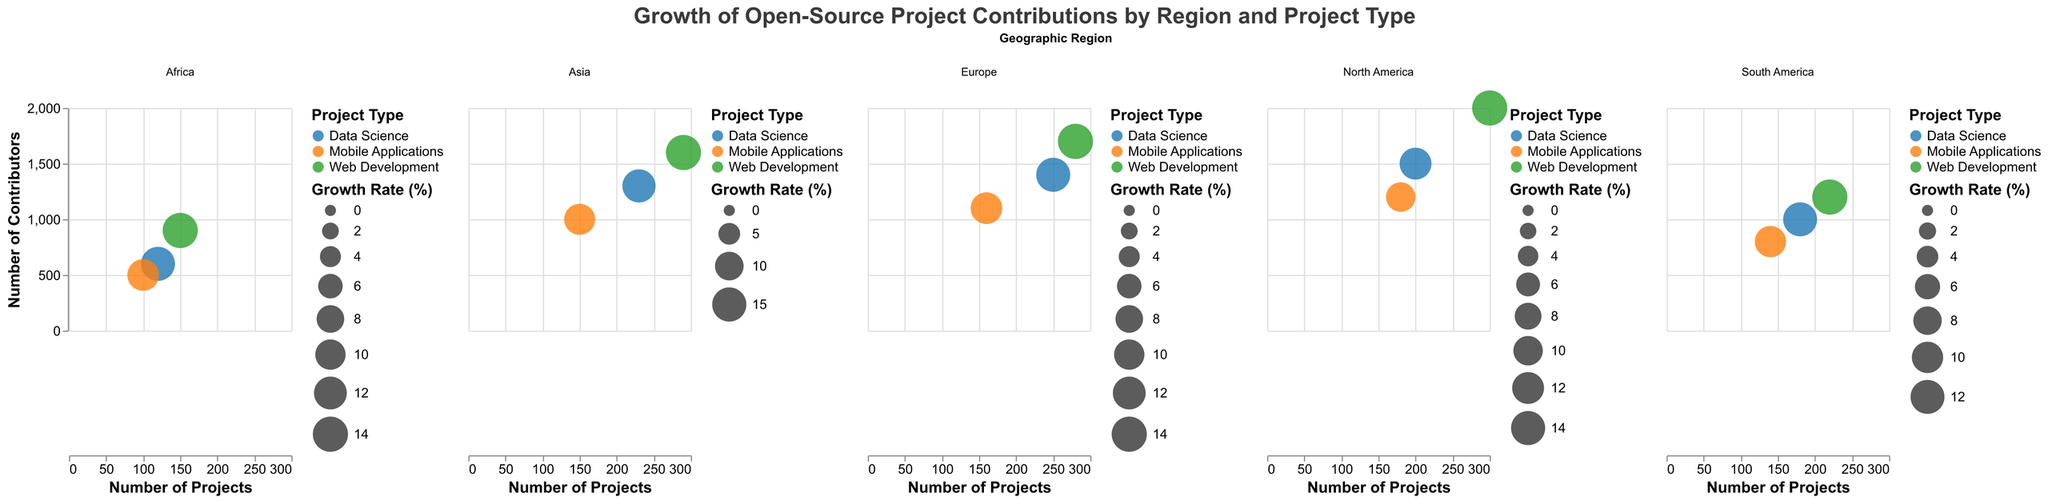Which geographic region has the highest number of contributors for web development? To determine the region with the highest number of contributors for web development, look at the subplot for each region and compare the "Number of Contributors" for the "Web Development" category. The North America subplot shows 2000 contributors, which is higher than other regions.
Answer: North America What is the growth rate for mobile applications in Asia? To find the growth rate for mobile applications in Asia, look at the Asia region in the subplot and identify the growth rate value associated with "Mobile Applications" bubble. The figure shows a growth rate of 12%.
Answer: 12% Which region has the lowest number of projects in data science? To determine the region with the lowest number of projects in data science, examine the number of projects for the "Data Science" category across all regions. Africa has 120 projects, which is the lowest number.
Answer: Africa Compare the growth rates for web development projects between North America and South America. Which one is higher? To compare growth rates, look at the "Web Development" bubbles in the North America and South America subplots. North America has a growth rate of 15%, while South America has a growth rate of 13%. Therefore, North America's growth rate is higher.
Answer: North America What is the total number of contributors for mobile applications in North America and Europe combined? To find the total number of contributors for mobile applications in North America and Europe, add the contributors in these regions: 1200 (North America) + 1100 (Europe). This results in a total of 2300 contributors.
Answer: 2300 Which project type in Europe has the highest growth rate, and what is the value? Look at the subplot for Europe and compare the growth rates for different project types. Web Development has a growth rate of 14%, Data Science has 13%, and Mobile Applications has 11%. The highest growth rate is for Web Development at 14%.
Answer: Web Development, 14% How does the number of projects in data science in Asia compare to the number of projects in mobile applications in North America? To compare, look at the "Projects" value for data science in Asia, which is 230, and for mobile applications in North America, which is 180. Asia's data science projects exceed North America's mobile application projects by 50.
Answer: Data science in Asia has 50 more projects What is the average growth rate for all project types in Africa? To find the average growth rate for all project types in Africa, sum the growth rates and divide by the number of project types: (14 + 13 + 11) / 3. This results in an average growth rate of 12.67%.
Answer: 12.67% Which regions have a higher number of contributors for data science than for mobile applications? Compare the number of contributors for data science and mobile applications in each region. In North America (1500 > 1200), Europe (1400 > 1100), and Asia (1300 > 1000), data science has more contributors than mobile applications.
Answer: North America, Europe, Asia 